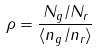<formula> <loc_0><loc_0><loc_500><loc_500>\rho = \frac { N _ { g } / N _ { r } } { \langle n _ { g } / n _ { r } \rangle }</formula> 